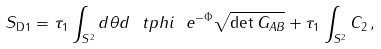<formula> <loc_0><loc_0><loc_500><loc_500>S _ { \text {D} 1 } = \tau _ { 1 } \int _ { S ^ { 2 } } d \theta d \ t p h i \ e ^ { - \Phi } \sqrt { \det { G _ { A B } } } + \tau _ { 1 } \int _ { S ^ { 2 } } C _ { 2 } \, ,</formula> 